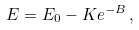Convert formula to latex. <formula><loc_0><loc_0><loc_500><loc_500>E = E _ { 0 } - K e ^ { - B } \, ,</formula> 